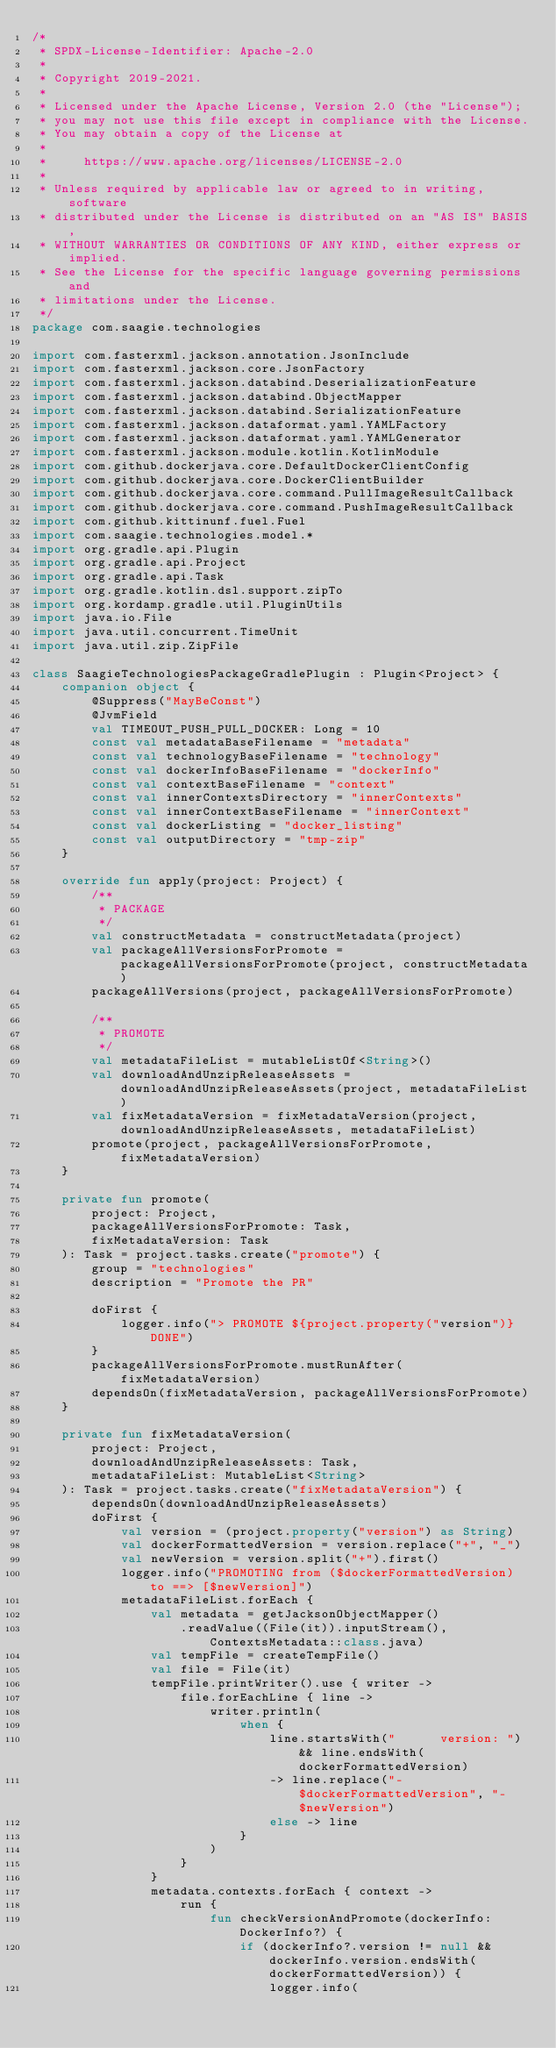<code> <loc_0><loc_0><loc_500><loc_500><_Kotlin_>/*
 * SPDX-License-Identifier: Apache-2.0
 *
 * Copyright 2019-2021.
 *
 * Licensed under the Apache License, Version 2.0 (the "License");
 * you may not use this file except in compliance with the License.
 * You may obtain a copy of the License at
 *
 *     https://www.apache.org/licenses/LICENSE-2.0
 *
 * Unless required by applicable law or agreed to in writing, software
 * distributed under the License is distributed on an "AS IS" BASIS,
 * WITHOUT WARRANTIES OR CONDITIONS OF ANY KIND, either express or implied.
 * See the License for the specific language governing permissions and
 * limitations under the License.
 */
package com.saagie.technologies

import com.fasterxml.jackson.annotation.JsonInclude
import com.fasterxml.jackson.core.JsonFactory
import com.fasterxml.jackson.databind.DeserializationFeature
import com.fasterxml.jackson.databind.ObjectMapper
import com.fasterxml.jackson.databind.SerializationFeature
import com.fasterxml.jackson.dataformat.yaml.YAMLFactory
import com.fasterxml.jackson.dataformat.yaml.YAMLGenerator
import com.fasterxml.jackson.module.kotlin.KotlinModule
import com.github.dockerjava.core.DefaultDockerClientConfig
import com.github.dockerjava.core.DockerClientBuilder
import com.github.dockerjava.core.command.PullImageResultCallback
import com.github.dockerjava.core.command.PushImageResultCallback
import com.github.kittinunf.fuel.Fuel
import com.saagie.technologies.model.*
import org.gradle.api.Plugin
import org.gradle.api.Project
import org.gradle.api.Task
import org.gradle.kotlin.dsl.support.zipTo
import org.kordamp.gradle.util.PluginUtils
import java.io.File
import java.util.concurrent.TimeUnit
import java.util.zip.ZipFile

class SaagieTechnologiesPackageGradlePlugin : Plugin<Project> {
    companion object {
        @Suppress("MayBeConst")
        @JvmField
        val TIMEOUT_PUSH_PULL_DOCKER: Long = 10
        const val metadataBaseFilename = "metadata"
        const val technologyBaseFilename = "technology"
        const val dockerInfoBaseFilename = "dockerInfo"
        const val contextBaseFilename = "context"
        const val innerContextsDirectory = "innerContexts"
        const val innerContextBaseFilename = "innerContext"
        const val dockerListing = "docker_listing"
        const val outputDirectory = "tmp-zip"
    }

    override fun apply(project: Project) {
        /**
         * PACKAGE
         */
        val constructMetadata = constructMetadata(project)
        val packageAllVersionsForPromote = packageAllVersionsForPromote(project, constructMetadata)
        packageAllVersions(project, packageAllVersionsForPromote)

        /**
         * PROMOTE
         */
        val metadataFileList = mutableListOf<String>()
        val downloadAndUnzipReleaseAssets = downloadAndUnzipReleaseAssets(project, metadataFileList)
        val fixMetadataVersion = fixMetadataVersion(project, downloadAndUnzipReleaseAssets, metadataFileList)
        promote(project, packageAllVersionsForPromote, fixMetadataVersion)
    }

    private fun promote(
        project: Project,
        packageAllVersionsForPromote: Task,
        fixMetadataVersion: Task
    ): Task = project.tasks.create("promote") {
        group = "technologies"
        description = "Promote the PR"

        doFirst {
            logger.info("> PROMOTE ${project.property("version")} DONE")
        }
        packageAllVersionsForPromote.mustRunAfter(fixMetadataVersion)
        dependsOn(fixMetadataVersion, packageAllVersionsForPromote)
    }

    private fun fixMetadataVersion(
        project: Project,
        downloadAndUnzipReleaseAssets: Task,
        metadataFileList: MutableList<String>
    ): Task = project.tasks.create("fixMetadataVersion") {
        dependsOn(downloadAndUnzipReleaseAssets)
        doFirst {
            val version = (project.property("version") as String)
            val dockerFormattedVersion = version.replace("+", "_")
            val newVersion = version.split("+").first()
            logger.info("PROMOTING from ($dockerFormattedVersion) to ==> [$newVersion]")
            metadataFileList.forEach {
                val metadata = getJacksonObjectMapper()
                    .readValue((File(it)).inputStream(), ContextsMetadata::class.java)
                val tempFile = createTempFile()
                val file = File(it)
                tempFile.printWriter().use { writer ->
                    file.forEachLine { line ->
                        writer.println(
                            when {
                                line.startsWith("      version: ") && line.endsWith(dockerFormattedVersion)
                                -> line.replace("-$dockerFormattedVersion", "-$newVersion")
                                else -> line
                            }
                        )
                    }
                }
                metadata.contexts.forEach { context ->
                    run {
                        fun checkVersionAndPromote(dockerInfo: DockerInfo?) {
                            if (dockerInfo?.version != null && dockerInfo.version.endsWith(dockerFormattedVersion)) {
                                logger.info(</code> 